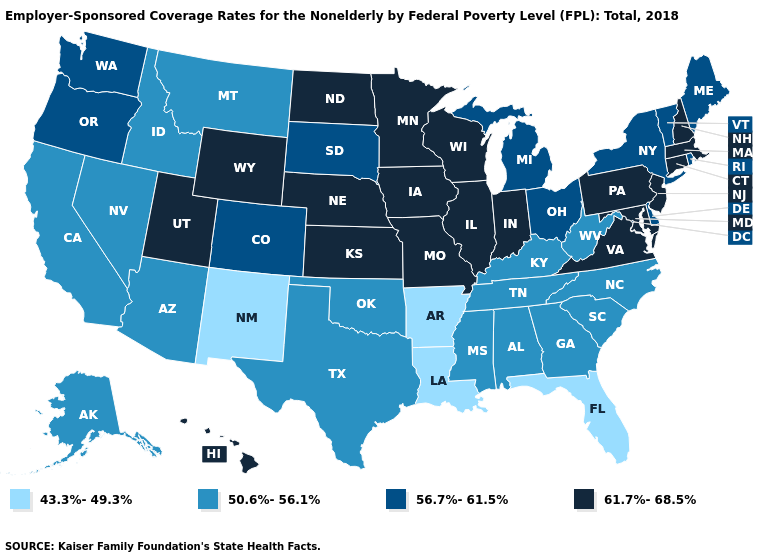What is the value of Arizona?
Short answer required. 50.6%-56.1%. Name the states that have a value in the range 56.7%-61.5%?
Be succinct. Colorado, Delaware, Maine, Michigan, New York, Ohio, Oregon, Rhode Island, South Dakota, Vermont, Washington. Among the states that border New Mexico , does Utah have the highest value?
Quick response, please. Yes. Does Ohio have the highest value in the MidWest?
Answer briefly. No. Name the states that have a value in the range 61.7%-68.5%?
Give a very brief answer. Connecticut, Hawaii, Illinois, Indiana, Iowa, Kansas, Maryland, Massachusetts, Minnesota, Missouri, Nebraska, New Hampshire, New Jersey, North Dakota, Pennsylvania, Utah, Virginia, Wisconsin, Wyoming. Name the states that have a value in the range 61.7%-68.5%?
Give a very brief answer. Connecticut, Hawaii, Illinois, Indiana, Iowa, Kansas, Maryland, Massachusetts, Minnesota, Missouri, Nebraska, New Hampshire, New Jersey, North Dakota, Pennsylvania, Utah, Virginia, Wisconsin, Wyoming. What is the value of Louisiana?
Write a very short answer. 43.3%-49.3%. What is the value of Michigan?
Write a very short answer. 56.7%-61.5%. What is the highest value in the USA?
Quick response, please. 61.7%-68.5%. Name the states that have a value in the range 61.7%-68.5%?
Short answer required. Connecticut, Hawaii, Illinois, Indiana, Iowa, Kansas, Maryland, Massachusetts, Minnesota, Missouri, Nebraska, New Hampshire, New Jersey, North Dakota, Pennsylvania, Utah, Virginia, Wisconsin, Wyoming. Among the states that border Georgia , which have the highest value?
Answer briefly. Alabama, North Carolina, South Carolina, Tennessee. What is the highest value in the USA?
Give a very brief answer. 61.7%-68.5%. Among the states that border Rhode Island , which have the lowest value?
Concise answer only. Connecticut, Massachusetts. Name the states that have a value in the range 43.3%-49.3%?
Be succinct. Arkansas, Florida, Louisiana, New Mexico. Among the states that border Ohio , does West Virginia have the lowest value?
Give a very brief answer. Yes. 